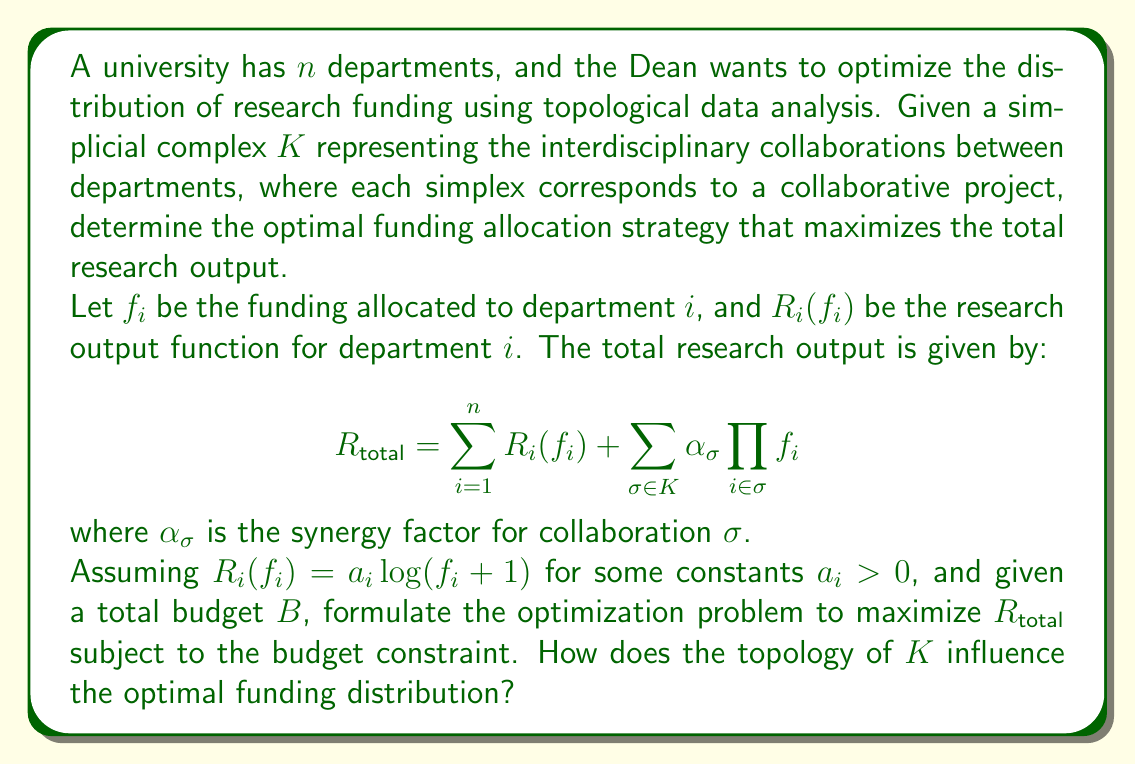Give your solution to this math problem. To solve this problem, we need to follow these steps:

1) Formulate the optimization problem:
   Maximize $R_{total}$ subject to the budget constraint:
   
   $$\max_{f_1,\ldots,f_n} \sum_{i=1}^n a_i \log(f_i + 1) + \sum_{\sigma \in K} \alpha_{\sigma} \prod_{i \in \sigma} f_i$$
   
   Subject to: $\sum_{i=1}^n f_i \leq B$ and $f_i \geq 0$ for all $i$

2) Analyze the influence of the topology of $K$:
   The topology of $K$ affects the optimization through the second term in $R_{total}$. Each simplex $\sigma$ in $K$ represents a collaborative project, and its dimension determines the number of departments involved.

   a) 0-simplices (vertices): Represent individual department contributions.
   b) 1-simplices (edges): Represent pairwise collaborations.
   c) Higher-dimensional simplices: Represent collaborations among three or more departments.

3) The optimal funding distribution will depend on:
   a) The values of $a_i$, which represent the individual research productivity of each department.
   b) The topology of $K$, which determines the structure of interdepartmental collaborations.
   c) The synergy factors $\alpha_{\sigma}$, which quantify the added value of collaborations.

4) General observations:
   a) Departments that participate in many high-dimensional simplices (i.e., have high degrees in the simplicial complex) are likely to receive more funding, as they contribute to many collaborative projects.
   b) The presence of high-dimensional simplices with large $\alpha_{\sigma}$ values will incentivize funding allocations that support these collaborations.
   c) The logarithmic nature of individual research output functions $R_i(f_i)$ suggests diminishing returns for large individual allocations, encouraging a more balanced distribution.

5) Solving the optimization problem:
   This is a non-linear optimization problem that can be solved using techniques such as the method of Lagrange multipliers or numerical optimization algorithms. The exact solution will depend on the specific values of $a_i$, $\alpha_{\sigma}$, and the structure of $K$.

The topology of $K$ influences the optimal funding distribution by creating a complex network of interdependencies between departments. Departments that are central in the topological structure (i.e., participate in many collaborations) are likely to receive more funding, as this maximizes the synergistic effects captured by the second term in $R_{total}$.
Answer: The optimal funding distribution is influenced by the topology of the simplicial complex $K$ representing interdepartmental collaborations. Departments that are more central in the topological structure, participating in many high-dimensional simplices with large synergy factors, are likely to receive more funding. The exact distribution depends on solving the non-linear optimization problem:

$$\max_{f_1,\ldots,f_n} \sum_{i=1}^n a_i \log(f_i + 1) + \sum_{\sigma \in K} \alpha_{\sigma} \prod_{i \in \sigma} f_i$$

Subject to: $\sum_{i=1}^n f_i \leq B$ and $f_i \geq 0$ for all $i$

This problem balances individual department productivity with the synergistic effects of collaborations, as captured by the topology of $K$. 